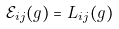Convert formula to latex. <formula><loc_0><loc_0><loc_500><loc_500>\mathcal { E } _ { i j } ( g ) = L _ { i j } ( g )</formula> 